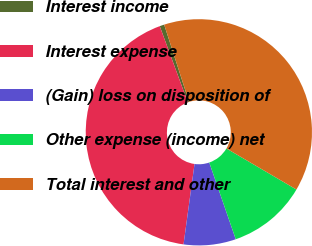Convert chart to OTSL. <chart><loc_0><loc_0><loc_500><loc_500><pie_chart><fcel>Interest income<fcel>Interest expense<fcel>(Gain) loss on disposition of<fcel>Other expense (income) net<fcel>Total interest and other<nl><fcel>0.66%<fcel>42.22%<fcel>7.45%<fcel>11.27%<fcel>38.4%<nl></chart> 